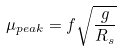Convert formula to latex. <formula><loc_0><loc_0><loc_500><loc_500>\mu _ { p e a k } = f \sqrt { \frac { g } { R _ { s } } }</formula> 